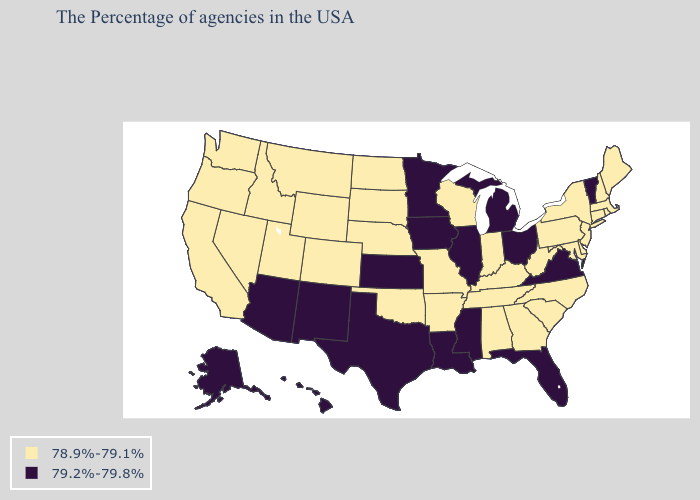Name the states that have a value in the range 78.9%-79.1%?
Write a very short answer. Maine, Massachusetts, Rhode Island, New Hampshire, Connecticut, New York, New Jersey, Delaware, Maryland, Pennsylvania, North Carolina, South Carolina, West Virginia, Georgia, Kentucky, Indiana, Alabama, Tennessee, Wisconsin, Missouri, Arkansas, Nebraska, Oklahoma, South Dakota, North Dakota, Wyoming, Colorado, Utah, Montana, Idaho, Nevada, California, Washington, Oregon. What is the highest value in the South ?
Be succinct. 79.2%-79.8%. Which states hav the highest value in the South?
Short answer required. Virginia, Florida, Mississippi, Louisiana, Texas. What is the value of Montana?
Be succinct. 78.9%-79.1%. Name the states that have a value in the range 78.9%-79.1%?
Answer briefly. Maine, Massachusetts, Rhode Island, New Hampshire, Connecticut, New York, New Jersey, Delaware, Maryland, Pennsylvania, North Carolina, South Carolina, West Virginia, Georgia, Kentucky, Indiana, Alabama, Tennessee, Wisconsin, Missouri, Arkansas, Nebraska, Oklahoma, South Dakota, North Dakota, Wyoming, Colorado, Utah, Montana, Idaho, Nevada, California, Washington, Oregon. Does Colorado have the highest value in the West?
Keep it brief. No. What is the value of Maryland?
Keep it brief. 78.9%-79.1%. Among the states that border South Dakota , which have the highest value?
Give a very brief answer. Minnesota, Iowa. Among the states that border Rhode Island , which have the lowest value?
Answer briefly. Massachusetts, Connecticut. What is the value of South Carolina?
Short answer required. 78.9%-79.1%. Name the states that have a value in the range 79.2%-79.8%?
Write a very short answer. Vermont, Virginia, Ohio, Florida, Michigan, Illinois, Mississippi, Louisiana, Minnesota, Iowa, Kansas, Texas, New Mexico, Arizona, Alaska, Hawaii. What is the value of Maine?
Quick response, please. 78.9%-79.1%. Is the legend a continuous bar?
Quick response, please. No. What is the value of North Carolina?
Be succinct. 78.9%-79.1%. Is the legend a continuous bar?
Quick response, please. No. 